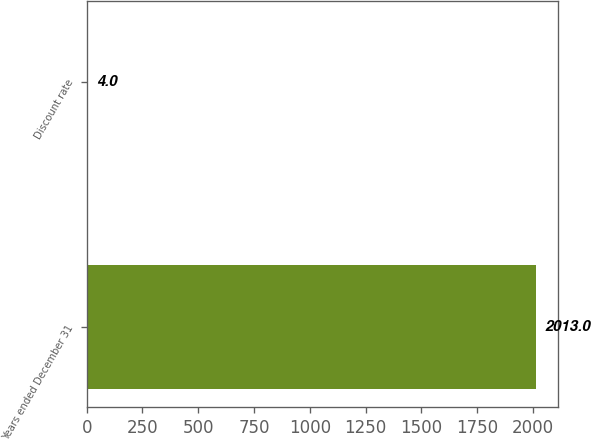Convert chart. <chart><loc_0><loc_0><loc_500><loc_500><bar_chart><fcel>Years ended December 31<fcel>Discount rate<nl><fcel>2013<fcel>4<nl></chart> 